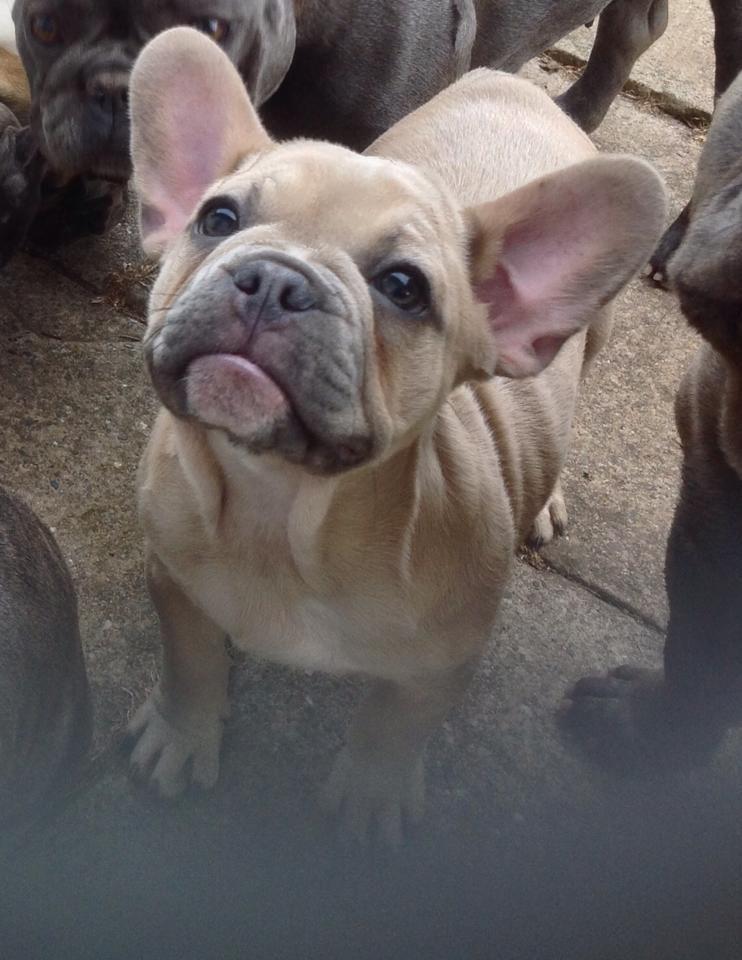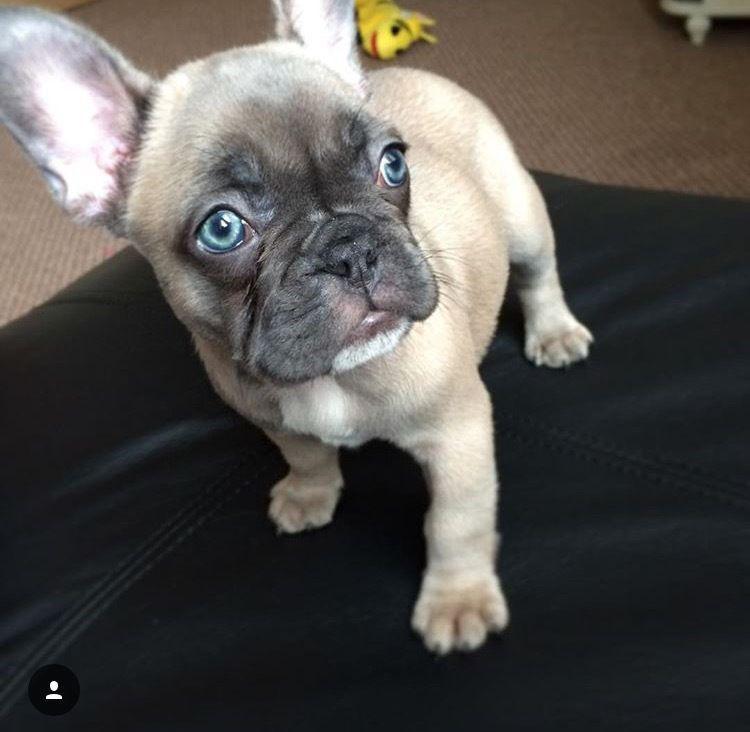The first image is the image on the left, the second image is the image on the right. Given the left and right images, does the statement "The right image shows a big-eared dog with light blue eyes, and the left image shows a dog standing on all fours with its body turned forward." hold true? Answer yes or no. Yes. The first image is the image on the left, the second image is the image on the right. For the images displayed, is the sentence "There are exactly two french bulldogs that are located outdoors." factually correct? Answer yes or no. No. 